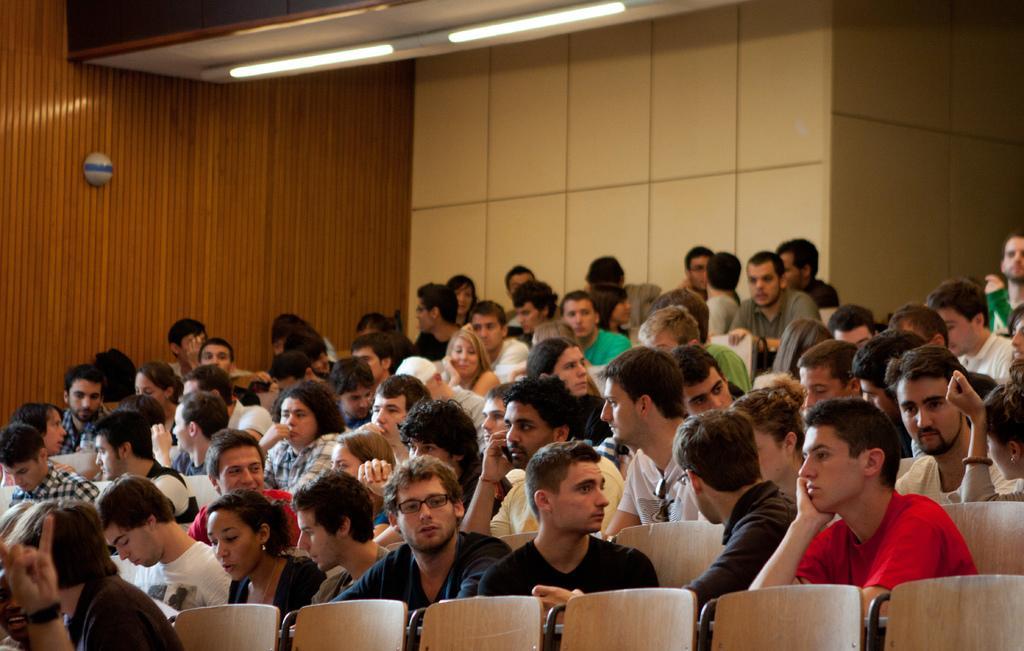Can you describe this image briefly? the picture consist of inside the room there are so many persons are sitting on chair and the background is white. 